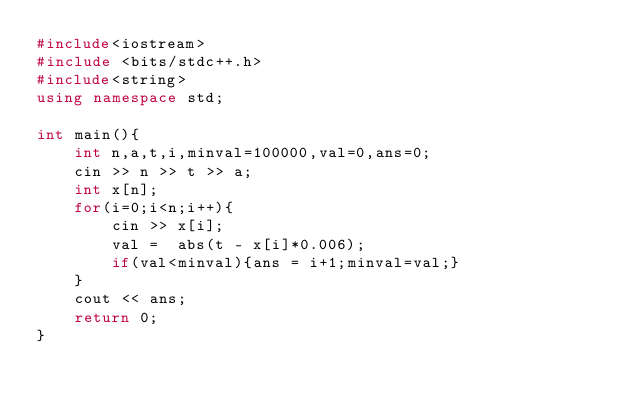Convert code to text. <code><loc_0><loc_0><loc_500><loc_500><_C++_>#include<iostream>
#include <bits/stdc++.h>
#include<string>
using namespace std;

int main(){
    int n,a,t,i,minval=100000,val=0,ans=0;
    cin >> n >> t >> a;
    int x[n];
    for(i=0;i<n;i++){
        cin >> x[i];
        val =  abs(t - x[i]*0.006);
        if(val<minval){ans = i+1;minval=val;}
    } 
    cout << ans;
    return 0;
}
</code> 